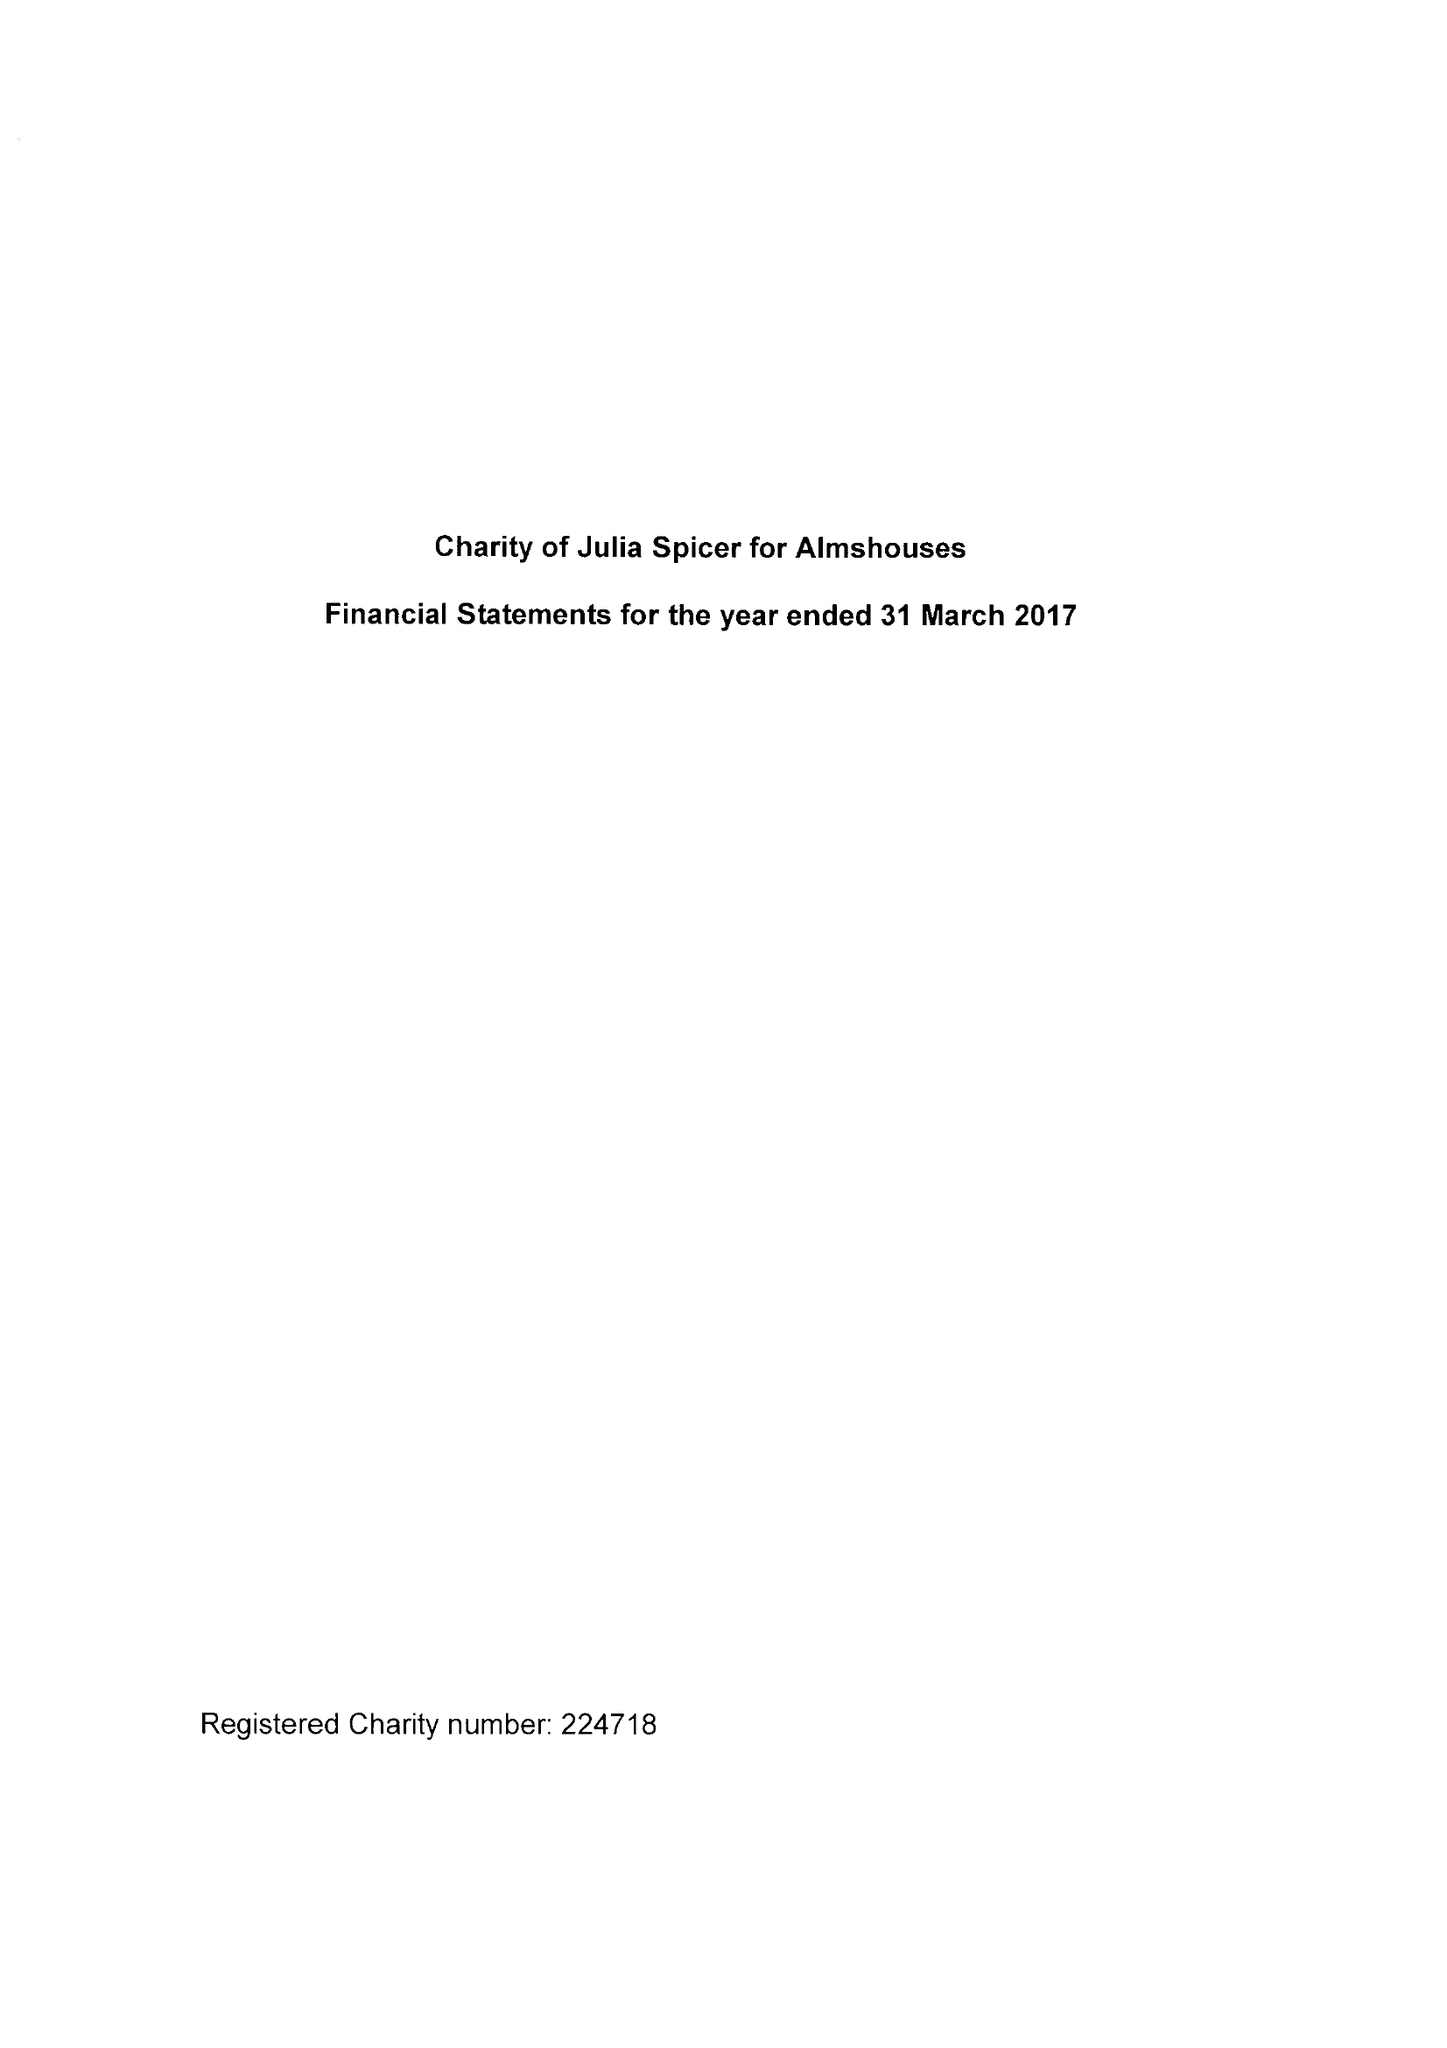What is the value for the charity_number?
Answer the question using a single word or phrase. 224718 